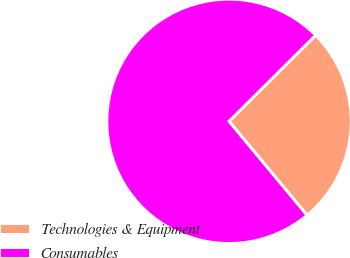Convert chart to OTSL. <chart><loc_0><loc_0><loc_500><loc_500><pie_chart><fcel>Technologies & Equipment<fcel>Consumables<nl><fcel>26.42%<fcel>73.58%<nl></chart> 